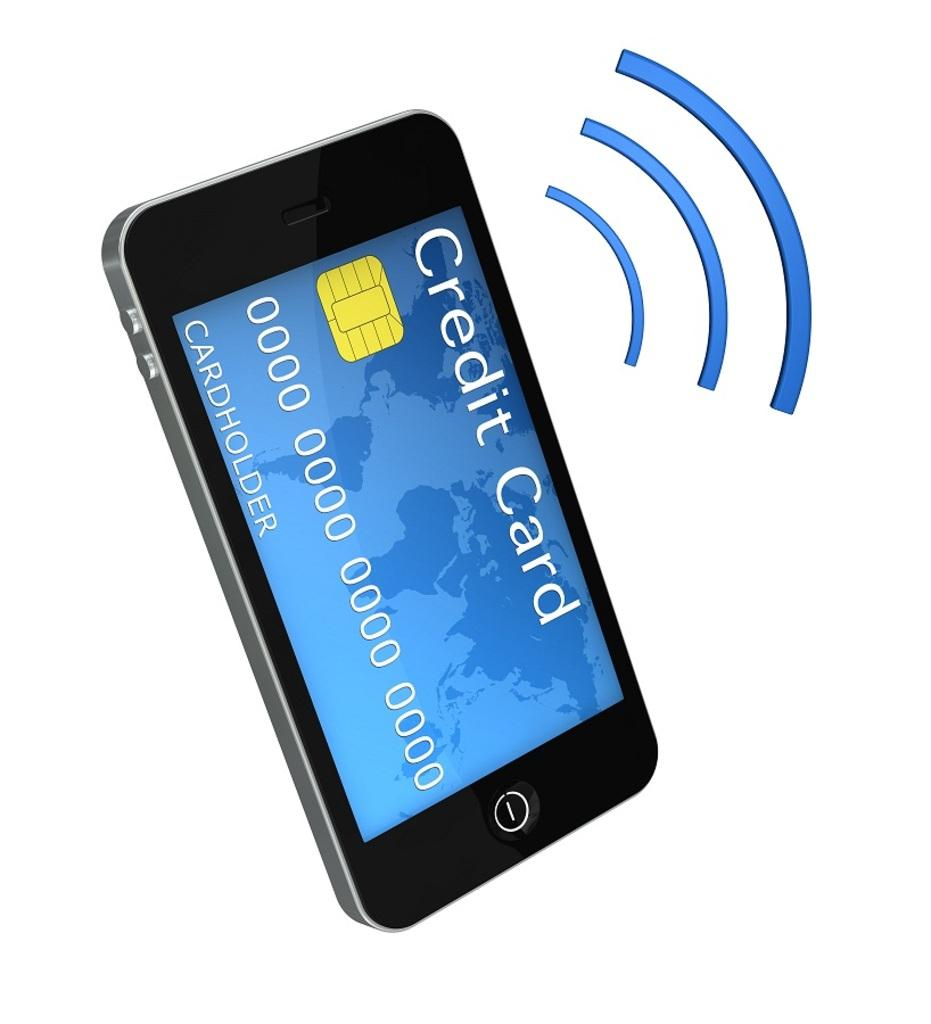<image>
Summarize the visual content of the image. A smart phone showing a faux credit card on the screen. 